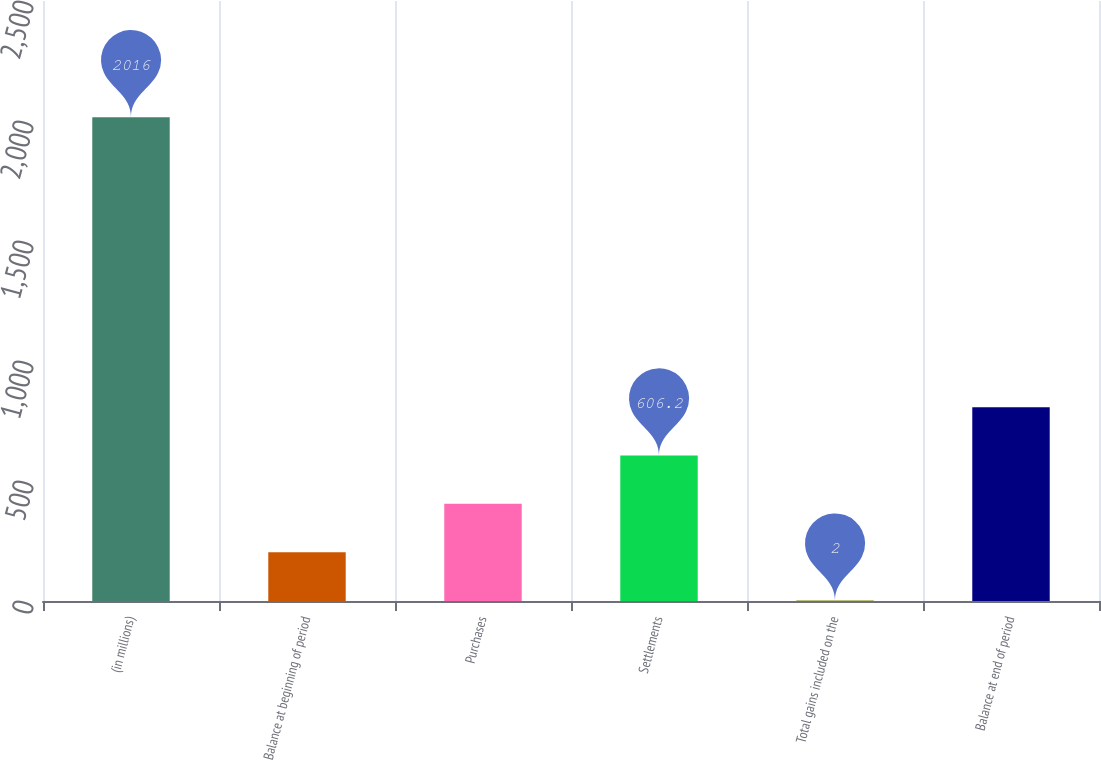<chart> <loc_0><loc_0><loc_500><loc_500><bar_chart><fcel>(in millions)<fcel>Balance at beginning of period<fcel>Purchases<fcel>Settlements<fcel>Total gains included on the<fcel>Balance at end of period<nl><fcel>2016<fcel>203.4<fcel>404.8<fcel>606.2<fcel>2<fcel>807.6<nl></chart> 